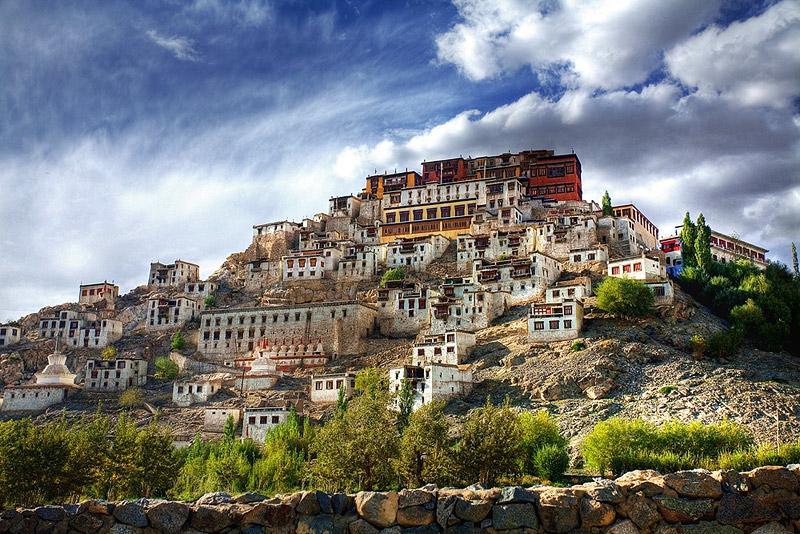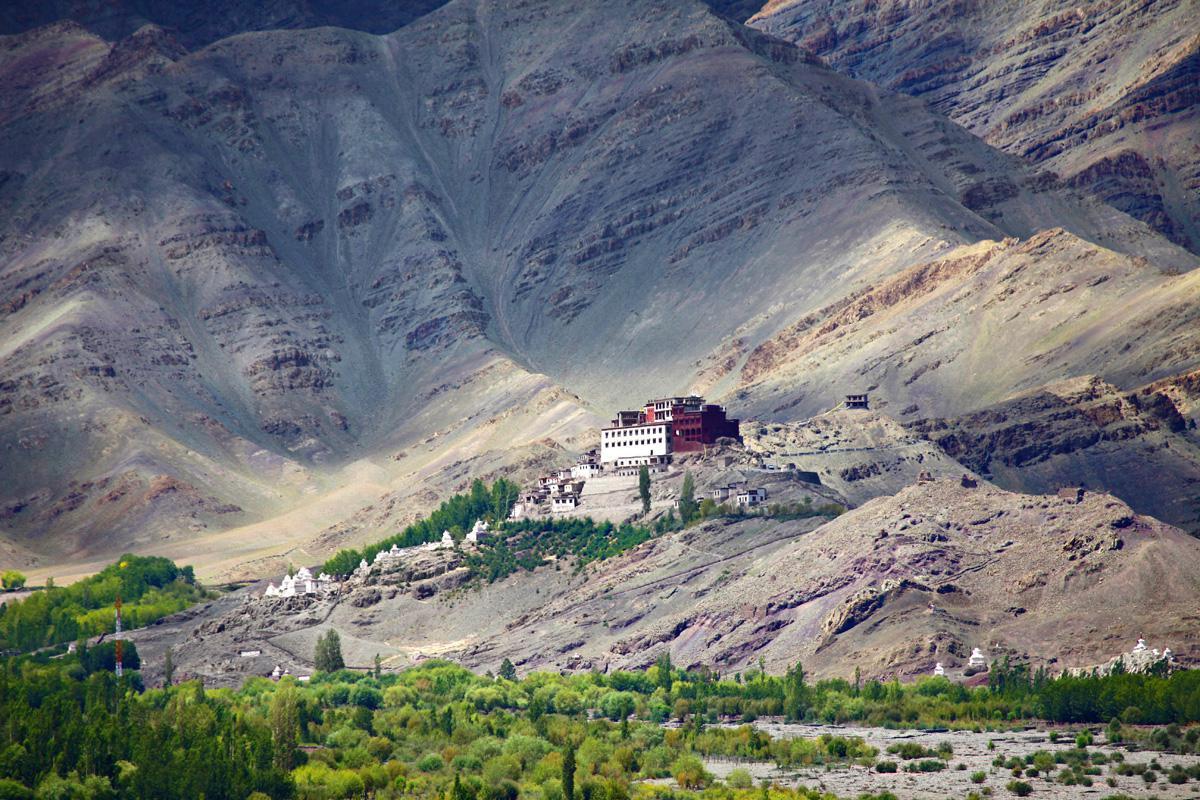The first image is the image on the left, the second image is the image on the right. Examine the images to the left and right. Is the description "A large golden shrine in the image of a person can be seen in both images." accurate? Answer yes or no. No. The first image is the image on the left, the second image is the image on the right. Examine the images to the left and right. Is the description "An image includes a golden seated figure with blue hair." accurate? Answer yes or no. No. 